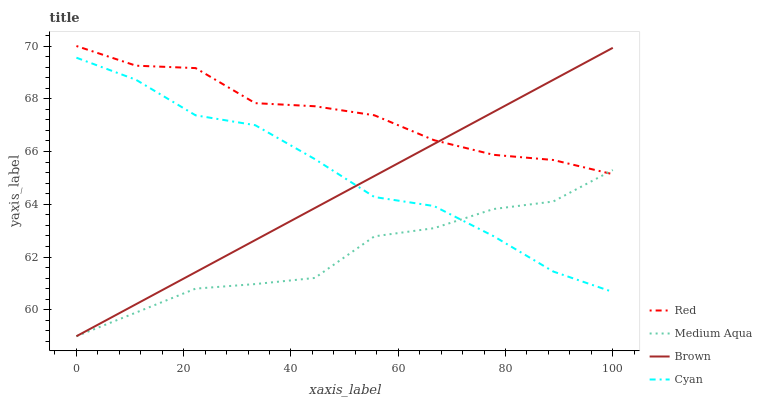Does Medium Aqua have the minimum area under the curve?
Answer yes or no. Yes. Does Red have the maximum area under the curve?
Answer yes or no. Yes. Does Red have the minimum area under the curve?
Answer yes or no. No. Does Medium Aqua have the maximum area under the curve?
Answer yes or no. No. Is Brown the smoothest?
Answer yes or no. Yes. Is Cyan the roughest?
Answer yes or no. Yes. Is Medium Aqua the smoothest?
Answer yes or no. No. Is Medium Aqua the roughest?
Answer yes or no. No. Does Brown have the lowest value?
Answer yes or no. Yes. Does Red have the lowest value?
Answer yes or no. No. Does Red have the highest value?
Answer yes or no. Yes. Does Medium Aqua have the highest value?
Answer yes or no. No. Is Cyan less than Red?
Answer yes or no. Yes. Is Red greater than Cyan?
Answer yes or no. Yes. Does Cyan intersect Medium Aqua?
Answer yes or no. Yes. Is Cyan less than Medium Aqua?
Answer yes or no. No. Is Cyan greater than Medium Aqua?
Answer yes or no. No. Does Cyan intersect Red?
Answer yes or no. No. 